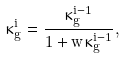Convert formula to latex. <formula><loc_0><loc_0><loc_500><loc_500>\kappa ^ { i } _ { g } = \frac { \kappa ^ { i - 1 } _ { g } } { 1 + w \kappa ^ { i - 1 } _ { g } } ,</formula> 